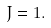<formula> <loc_0><loc_0><loc_500><loc_500>J = 1 .</formula> 